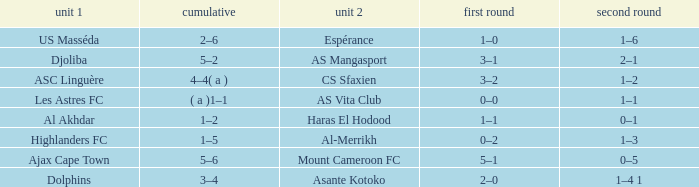What is the team 1 with team 2 Mount Cameroon FC? Ajax Cape Town. 